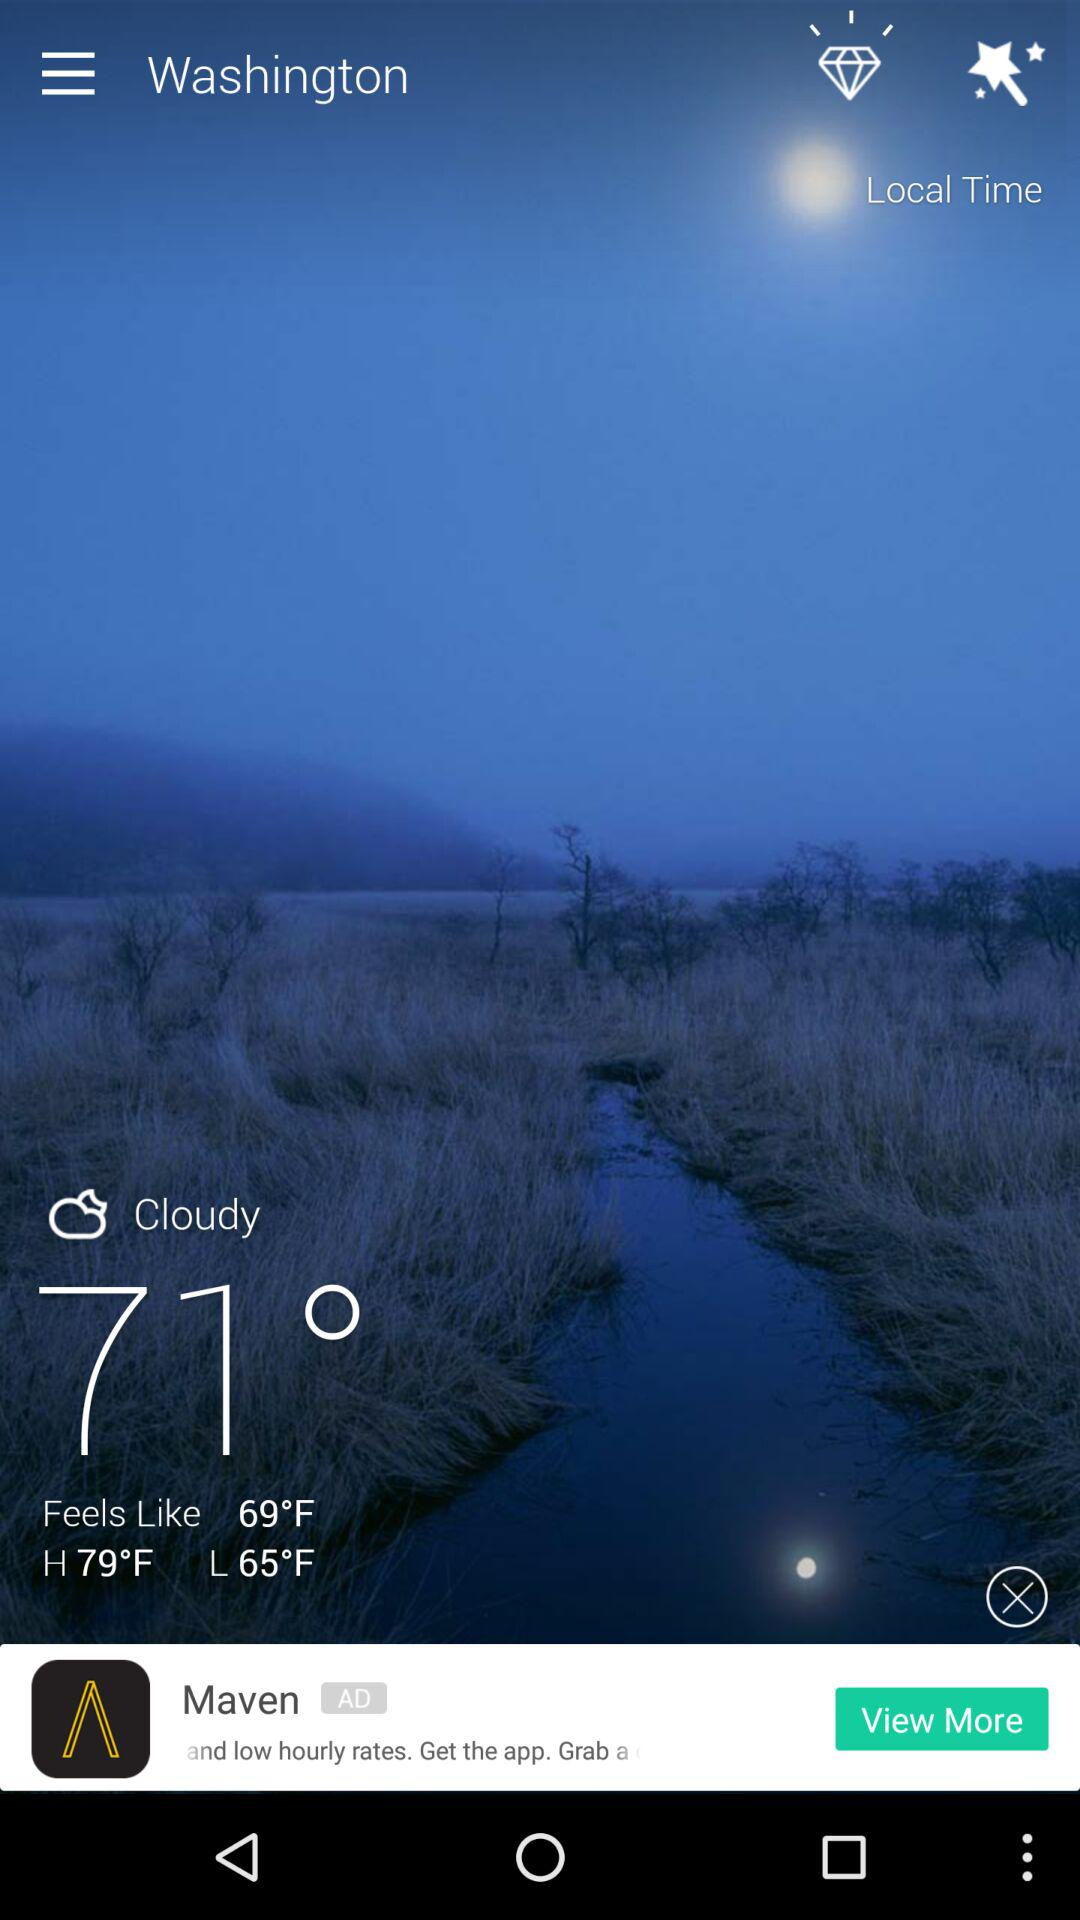What is the difference in degrees between the high and low temperatures?
Answer the question using a single word or phrase. 14 